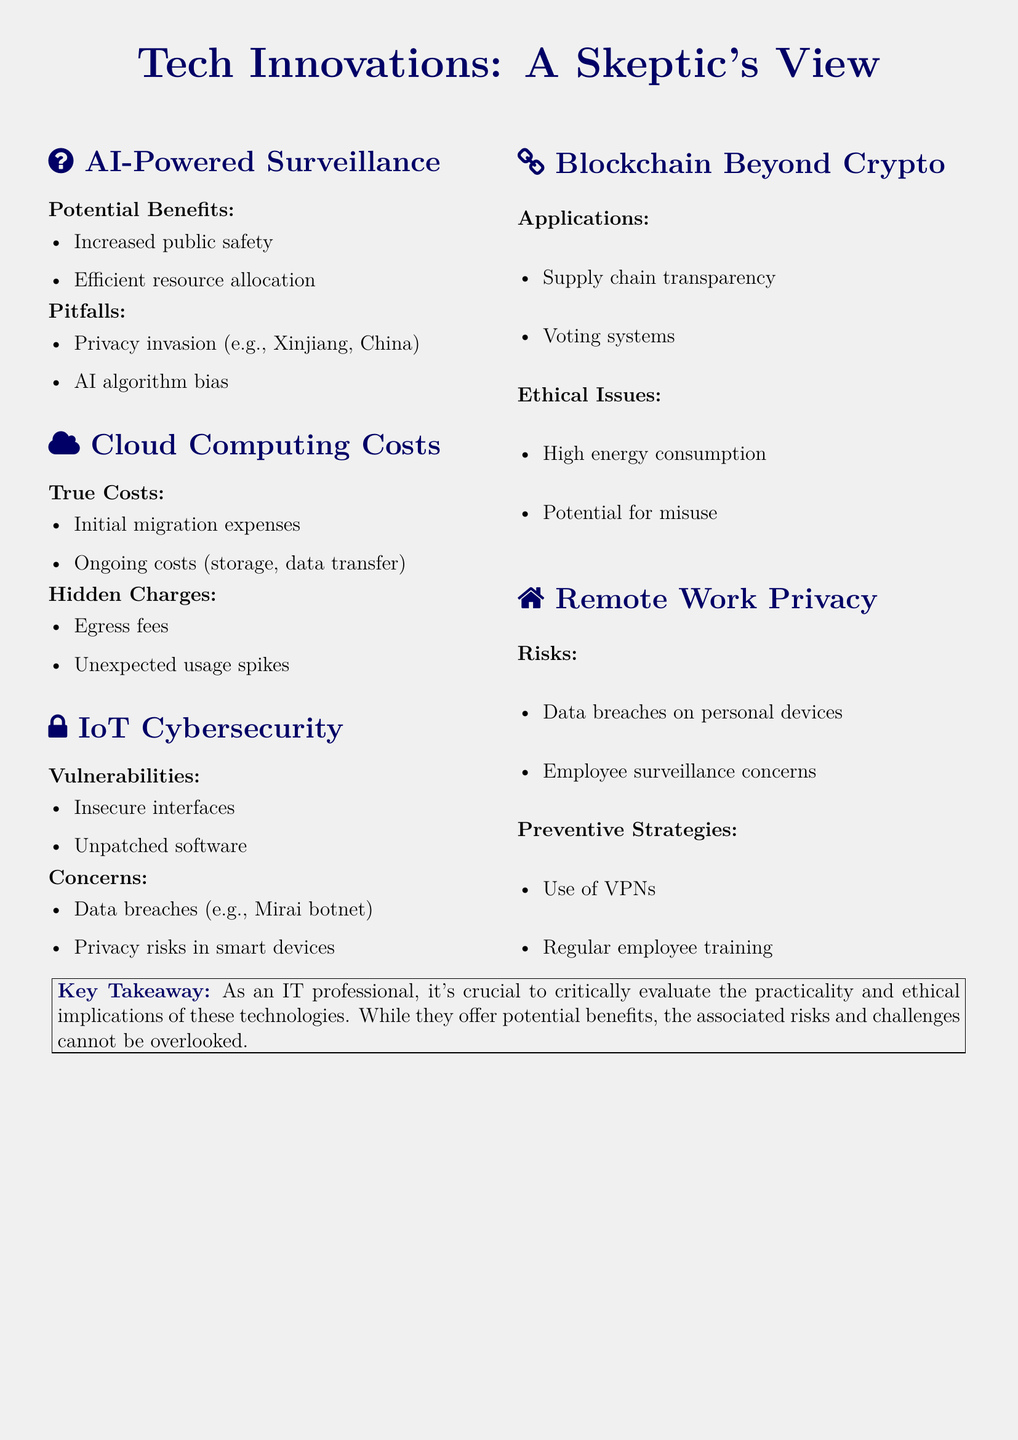What are the potential benefits of AI-powered surveillance? The potential benefits include increased public safety and efficient resource allocation.
Answer: Increased public safety, efficient resource allocation What ethical issue is associated with blockchain? The ethical issues discussed in the document include high energy consumption and the potential for misuse.
Answer: High energy consumption, potential for misuse What type of costs are included in cloud computing? The true costs of cloud computing include initial migration expenses and ongoing costs such as storage and data transfer.
Answer: Initial migration expenses, ongoing costs What vulnerabilities are noted in IoT cybersecurity? The vulnerabilities highlighted include insecure interfaces and unpatched software.
Answer: Insecure interfaces, unpatched software What preventive strategy is suggested for remote work risks? The document suggests using VPNs and providing regular employee training as preventive strategies.
Answer: Use of VPNs, regular employee training What is a real-life example of data breaches mentioned? A specific example given is the Mirai botnet.
Answer: Mirai botnet What are the main pitfalls of AI-powered surveillance? The main pitfalls are privacy invasion and AI algorithm bias.
Answer: Privacy invasion, AI algorithm bias What is the key takeaway from the document for IT professionals? The key takeaway emphasizes the importance of critically evaluating the practicality and ethical implications of technologies.
Answer: Evaluate practicality and ethical implications 